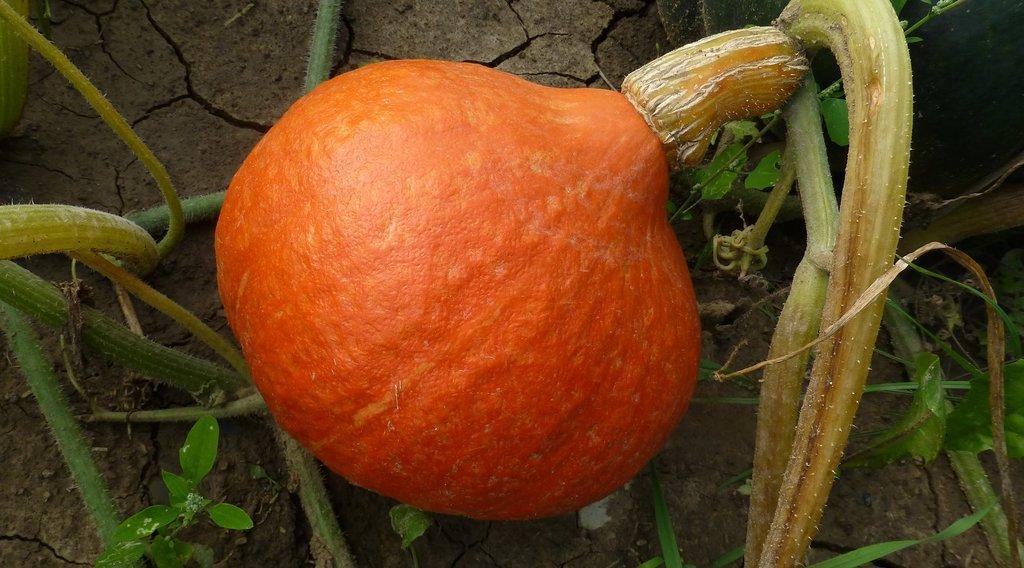Please provide a concise description of this image. In this image there is a pumpkin to a plant which is on the land. There are few plants on the land. 